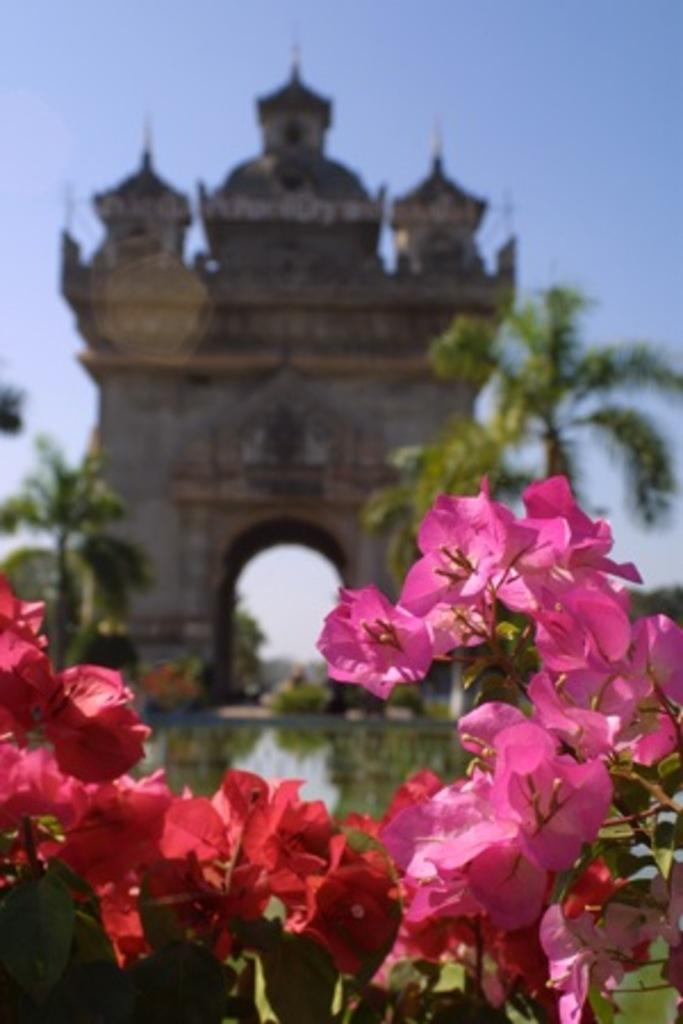What type of plants can be seen in the image? There are colorful flowers in the image. What natural element is visible in the image? There is water visible in the image. Can you describe the architectural feature in the image? There is a building with an arch in the image. What type of vegetation is present in the image? There are trees in the image. What color is the ink used to write on the egg in the image? There is no egg or ink present in the image. In which direction are the flowers facing in the image? The direction in which the flowers are facing cannot be determined from the image, as they are not facing a specific direction. 